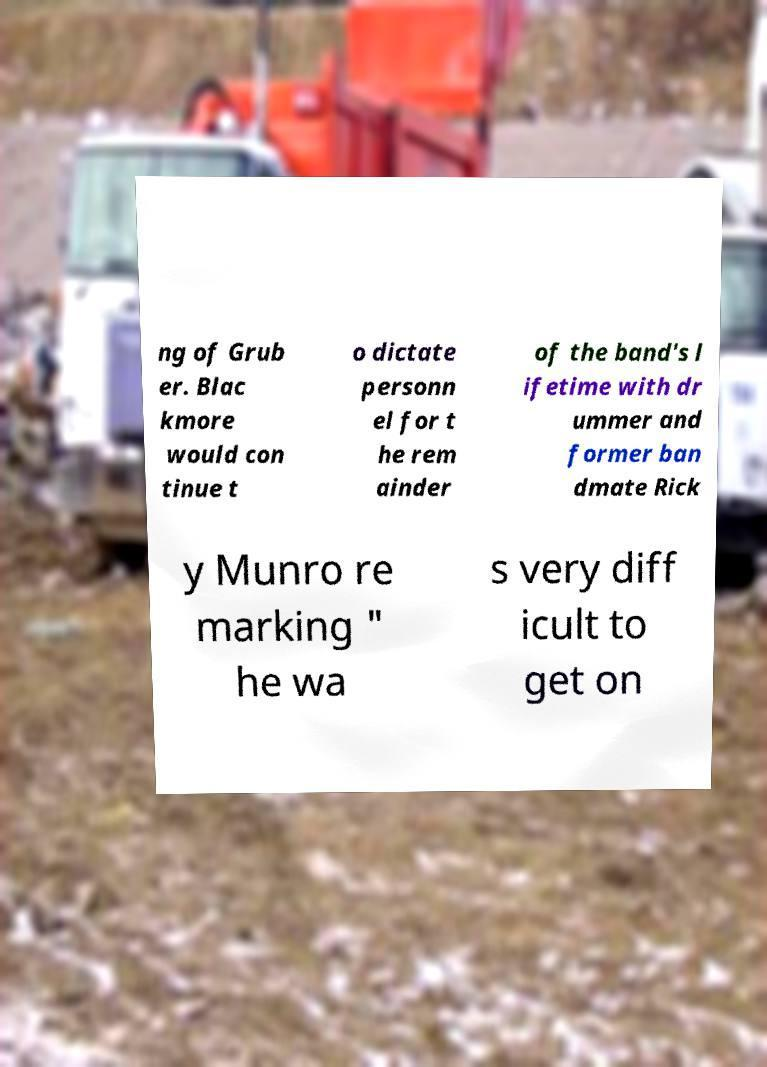I need the written content from this picture converted into text. Can you do that? ng of Grub er. Blac kmore would con tinue t o dictate personn el for t he rem ainder of the band's l ifetime with dr ummer and former ban dmate Rick y Munro re marking " he wa s very diff icult to get on 